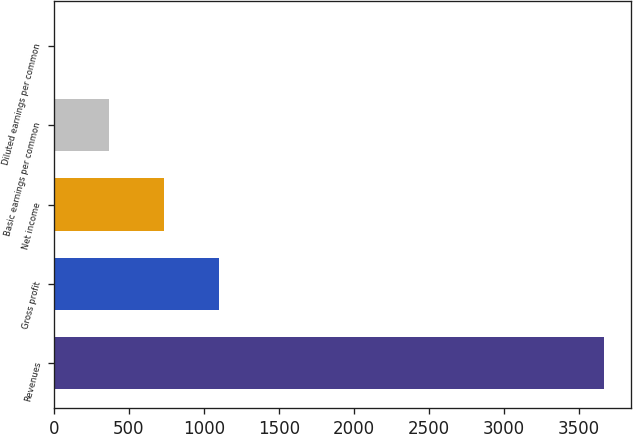<chart> <loc_0><loc_0><loc_500><loc_500><bar_chart><fcel>Revenues<fcel>Gross profit<fcel>Net income<fcel>Basic earnings per common<fcel>Diluted earnings per common<nl><fcel>3667.8<fcel>1101<fcel>734.31<fcel>367.62<fcel>0.93<nl></chart> 